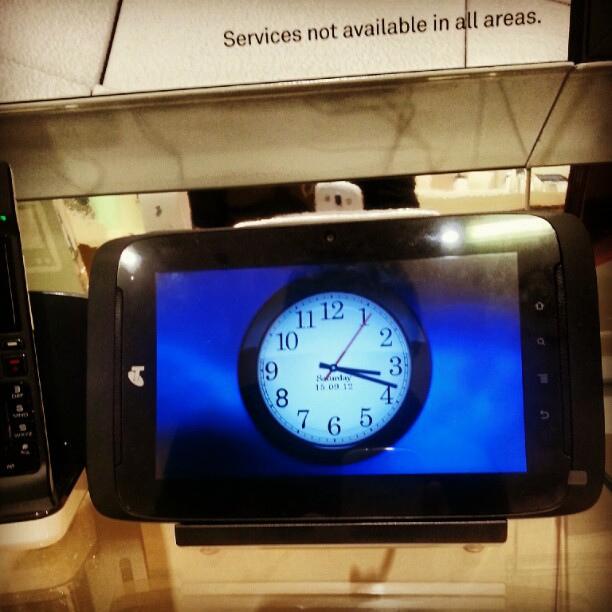What shape is the phone?
Concise answer only. Rectangle. Is it Am or Pm?
Keep it brief. Pm. What time is it?
Concise answer only. 3:18. Is this a real clock?
Answer briefly. No. 